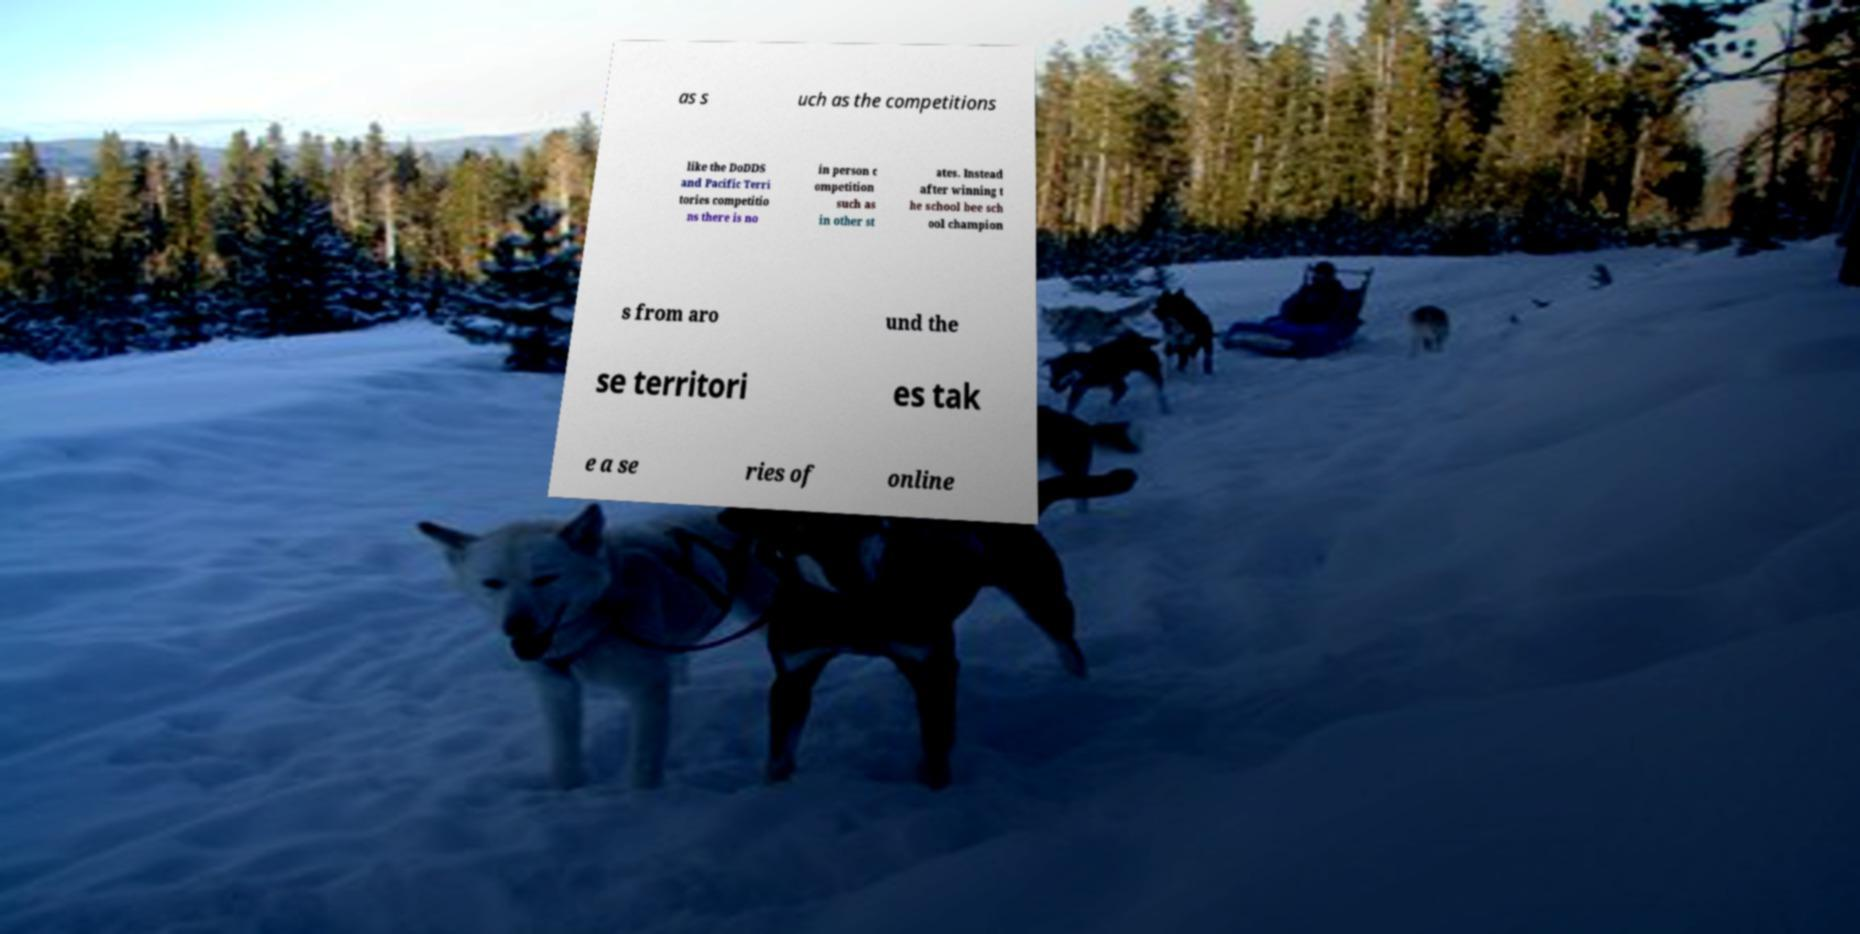Can you accurately transcribe the text from the provided image for me? as s uch as the competitions like the DoDDS and Pacific Terri tories competitio ns there is no in person c ompetition such as in other st ates. Instead after winning t he school bee sch ool champion s from aro und the se territori es tak e a se ries of online 